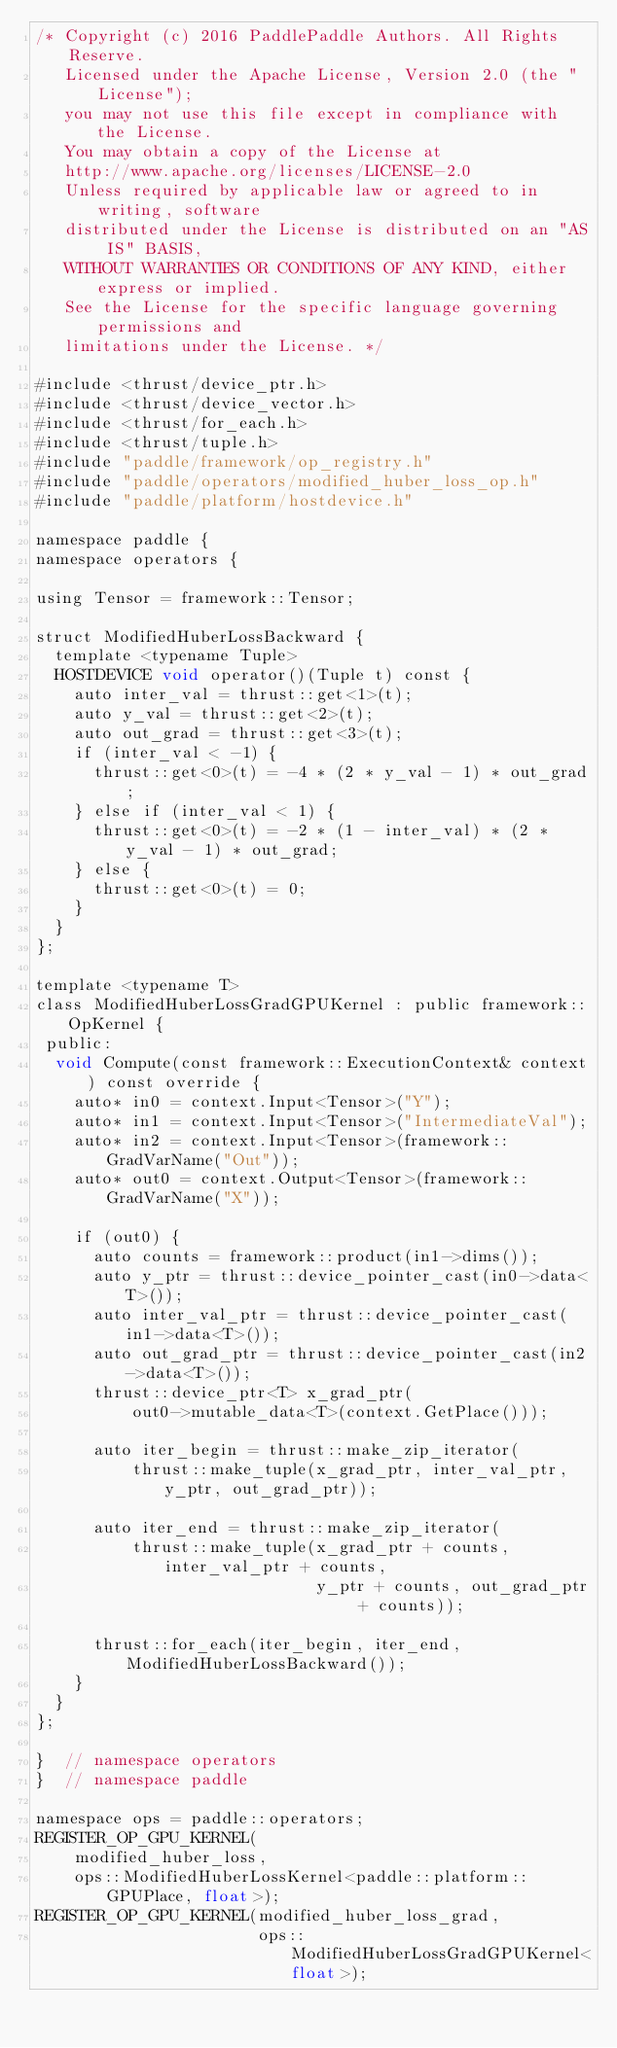<code> <loc_0><loc_0><loc_500><loc_500><_Cuda_>/* Copyright (c) 2016 PaddlePaddle Authors. All Rights Reserve.
   Licensed under the Apache License, Version 2.0 (the "License");
   you may not use this file except in compliance with the License.
   You may obtain a copy of the License at
   http://www.apache.org/licenses/LICENSE-2.0
   Unless required by applicable law or agreed to in writing, software
   distributed under the License is distributed on an "AS IS" BASIS,
   WITHOUT WARRANTIES OR CONDITIONS OF ANY KIND, either express or implied.
   See the License for the specific language governing permissions and
   limitations under the License. */

#include <thrust/device_ptr.h>
#include <thrust/device_vector.h>
#include <thrust/for_each.h>
#include <thrust/tuple.h>
#include "paddle/framework/op_registry.h"
#include "paddle/operators/modified_huber_loss_op.h"
#include "paddle/platform/hostdevice.h"

namespace paddle {
namespace operators {

using Tensor = framework::Tensor;

struct ModifiedHuberLossBackward {
  template <typename Tuple>
  HOSTDEVICE void operator()(Tuple t) const {
    auto inter_val = thrust::get<1>(t);
    auto y_val = thrust::get<2>(t);
    auto out_grad = thrust::get<3>(t);
    if (inter_val < -1) {
      thrust::get<0>(t) = -4 * (2 * y_val - 1) * out_grad;
    } else if (inter_val < 1) {
      thrust::get<0>(t) = -2 * (1 - inter_val) * (2 * y_val - 1) * out_grad;
    } else {
      thrust::get<0>(t) = 0;
    }
  }
};

template <typename T>
class ModifiedHuberLossGradGPUKernel : public framework::OpKernel {
 public:
  void Compute(const framework::ExecutionContext& context) const override {
    auto* in0 = context.Input<Tensor>("Y");
    auto* in1 = context.Input<Tensor>("IntermediateVal");
    auto* in2 = context.Input<Tensor>(framework::GradVarName("Out"));
    auto* out0 = context.Output<Tensor>(framework::GradVarName("X"));

    if (out0) {
      auto counts = framework::product(in1->dims());
      auto y_ptr = thrust::device_pointer_cast(in0->data<T>());
      auto inter_val_ptr = thrust::device_pointer_cast(in1->data<T>());
      auto out_grad_ptr = thrust::device_pointer_cast(in2->data<T>());
      thrust::device_ptr<T> x_grad_ptr(
          out0->mutable_data<T>(context.GetPlace()));

      auto iter_begin = thrust::make_zip_iterator(
          thrust::make_tuple(x_grad_ptr, inter_val_ptr, y_ptr, out_grad_ptr));

      auto iter_end = thrust::make_zip_iterator(
          thrust::make_tuple(x_grad_ptr + counts, inter_val_ptr + counts,
                             y_ptr + counts, out_grad_ptr + counts));

      thrust::for_each(iter_begin, iter_end, ModifiedHuberLossBackward());
    }
  }
};

}  // namespace operators
}  // namespace paddle

namespace ops = paddle::operators;
REGISTER_OP_GPU_KERNEL(
    modified_huber_loss,
    ops::ModifiedHuberLossKernel<paddle::platform::GPUPlace, float>);
REGISTER_OP_GPU_KERNEL(modified_huber_loss_grad,
                       ops::ModifiedHuberLossGradGPUKernel<float>);
</code> 